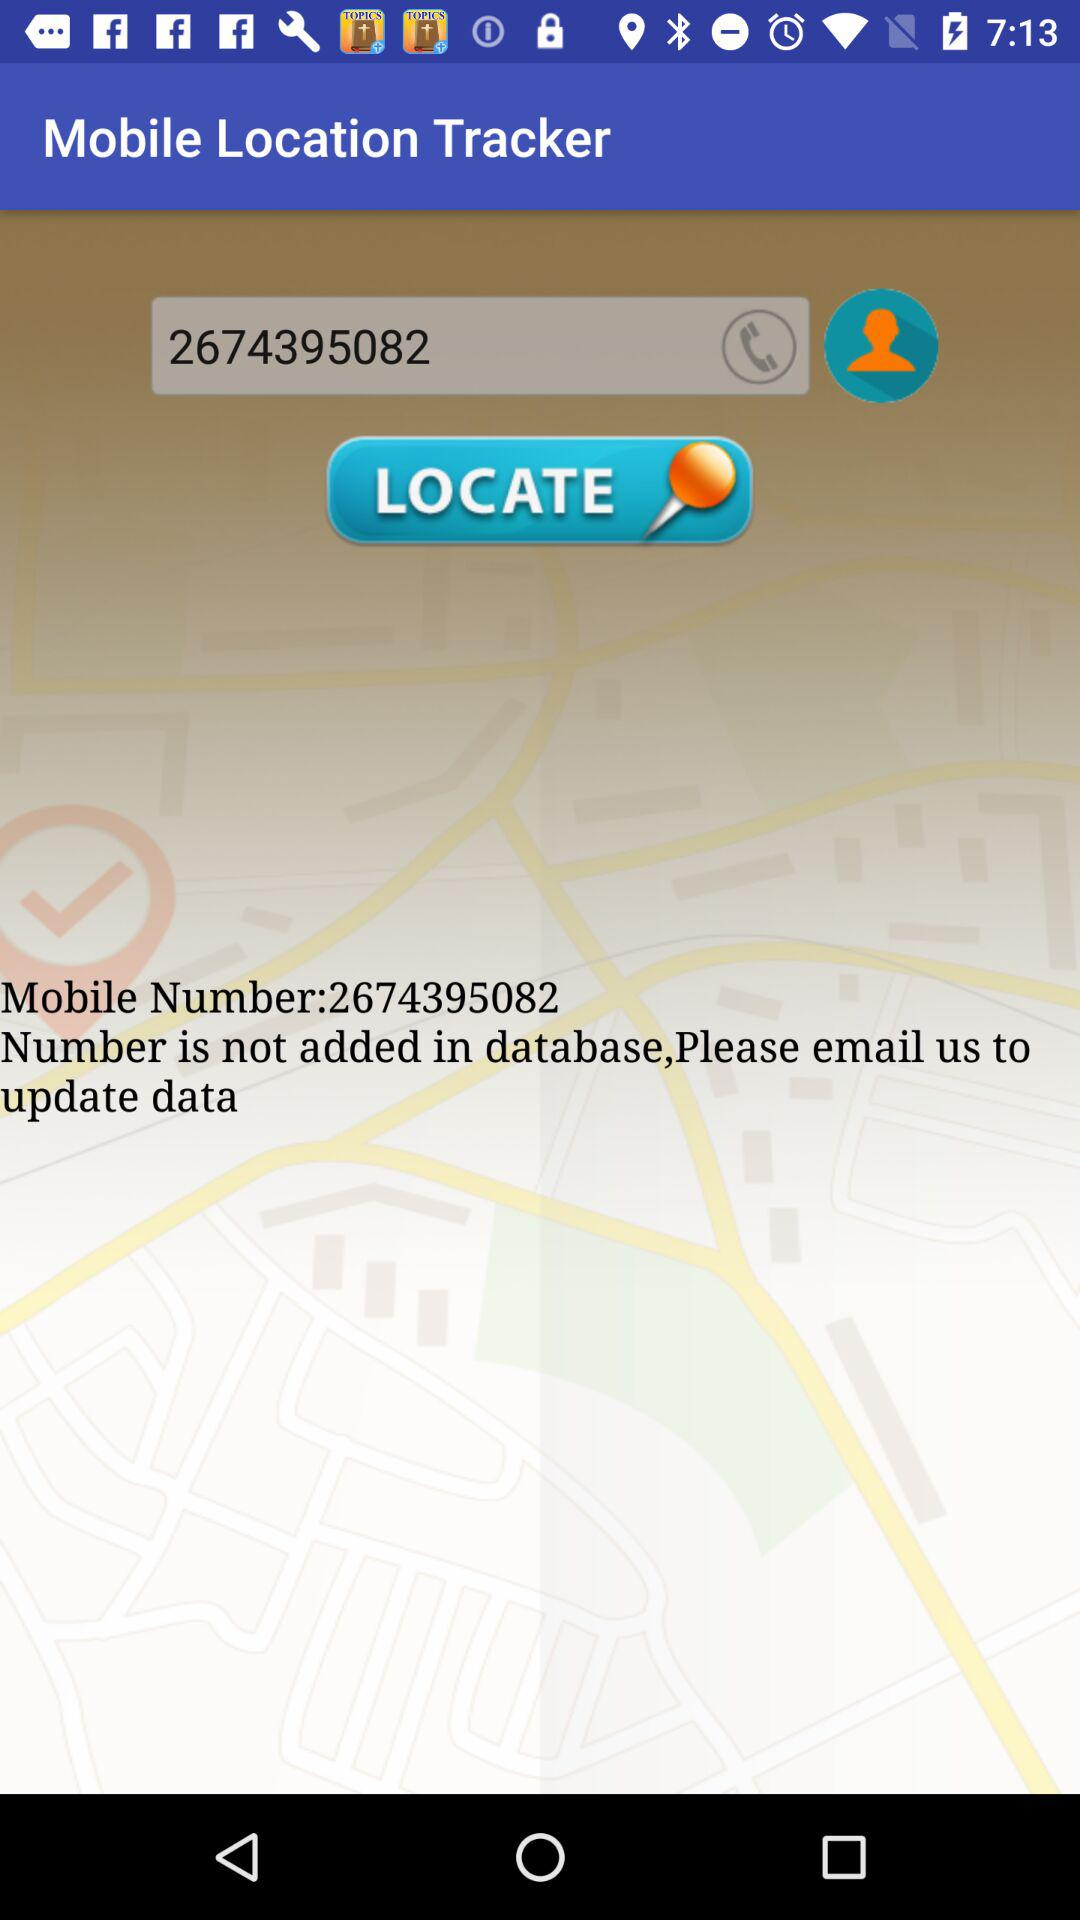What is the mobile number? The mobile number is 2674395082. 